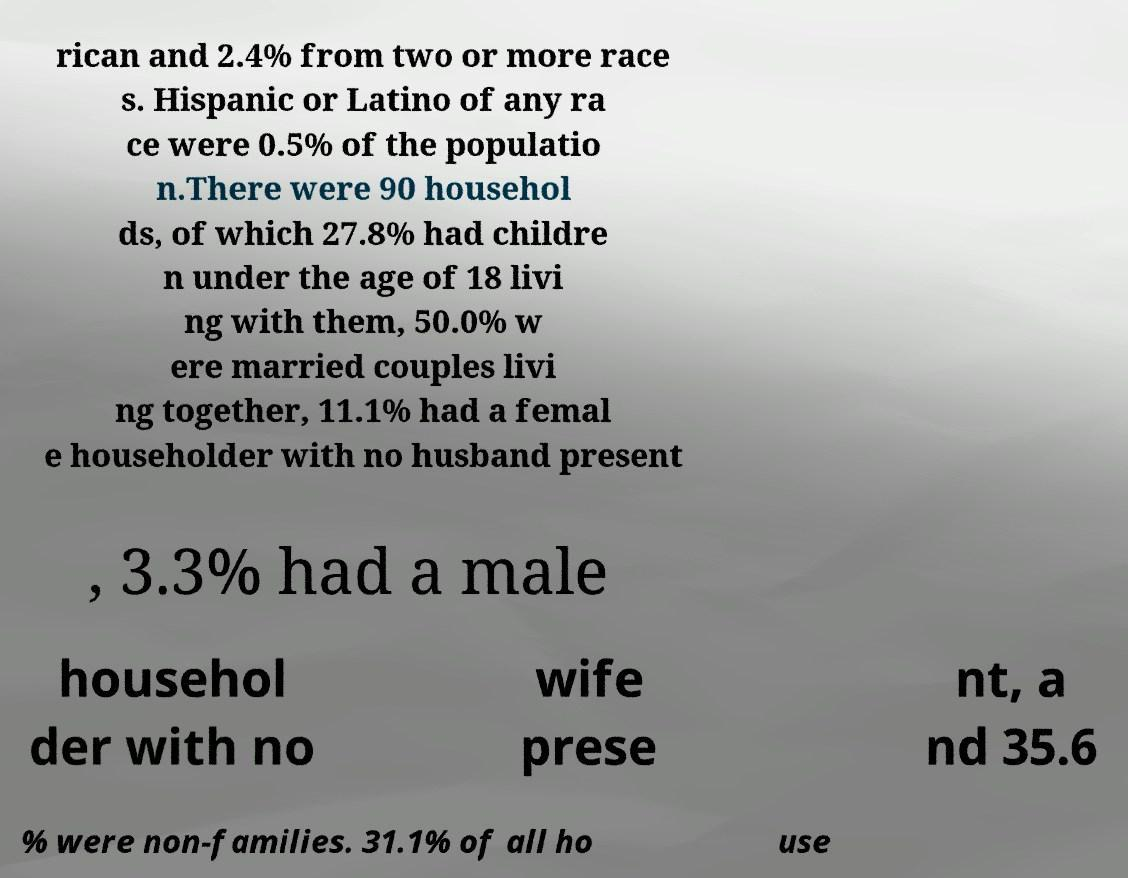What messages or text are displayed in this image? I need them in a readable, typed format. rican and 2.4% from two or more race s. Hispanic or Latino of any ra ce were 0.5% of the populatio n.There were 90 househol ds, of which 27.8% had childre n under the age of 18 livi ng with them, 50.0% w ere married couples livi ng together, 11.1% had a femal e householder with no husband present , 3.3% had a male househol der with no wife prese nt, a nd 35.6 % were non-families. 31.1% of all ho use 